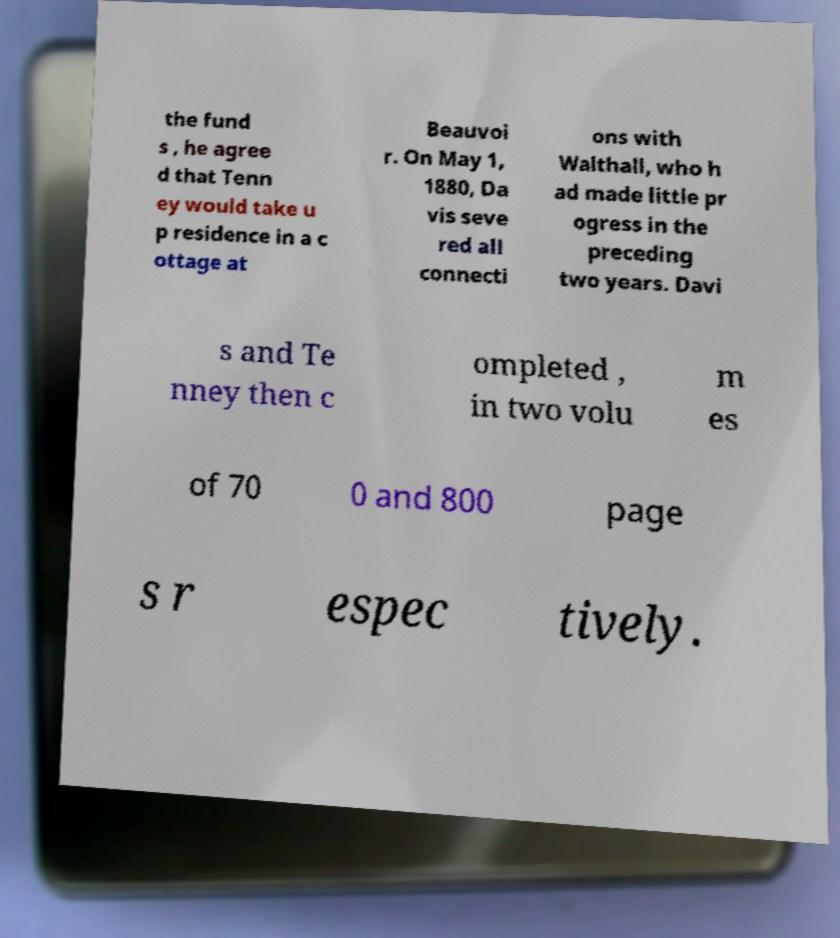I need the written content from this picture converted into text. Can you do that? the fund s , he agree d that Tenn ey would take u p residence in a c ottage at Beauvoi r. On May 1, 1880, Da vis seve red all connecti ons with Walthall, who h ad made little pr ogress in the preceding two years. Davi s and Te nney then c ompleted , in two volu m es of 70 0 and 800 page s r espec tively. 